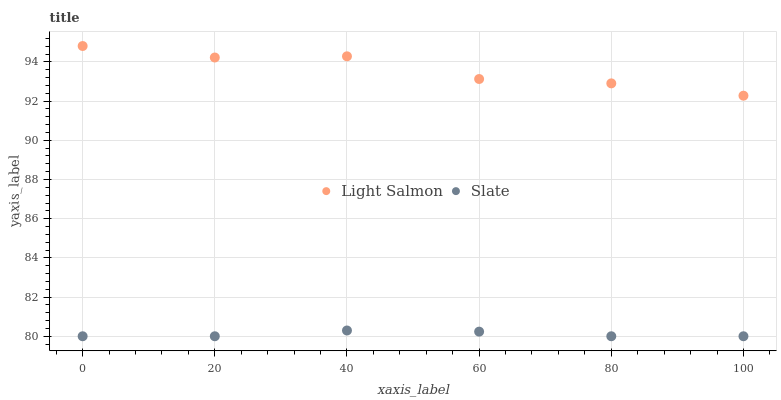Does Slate have the minimum area under the curve?
Answer yes or no. Yes. Does Light Salmon have the maximum area under the curve?
Answer yes or no. Yes. Does Slate have the maximum area under the curve?
Answer yes or no. No. Is Slate the smoothest?
Answer yes or no. Yes. Is Light Salmon the roughest?
Answer yes or no. Yes. Is Slate the roughest?
Answer yes or no. No. Does Slate have the lowest value?
Answer yes or no. Yes. Does Light Salmon have the highest value?
Answer yes or no. Yes. Does Slate have the highest value?
Answer yes or no. No. Is Slate less than Light Salmon?
Answer yes or no. Yes. Is Light Salmon greater than Slate?
Answer yes or no. Yes. Does Slate intersect Light Salmon?
Answer yes or no. No. 